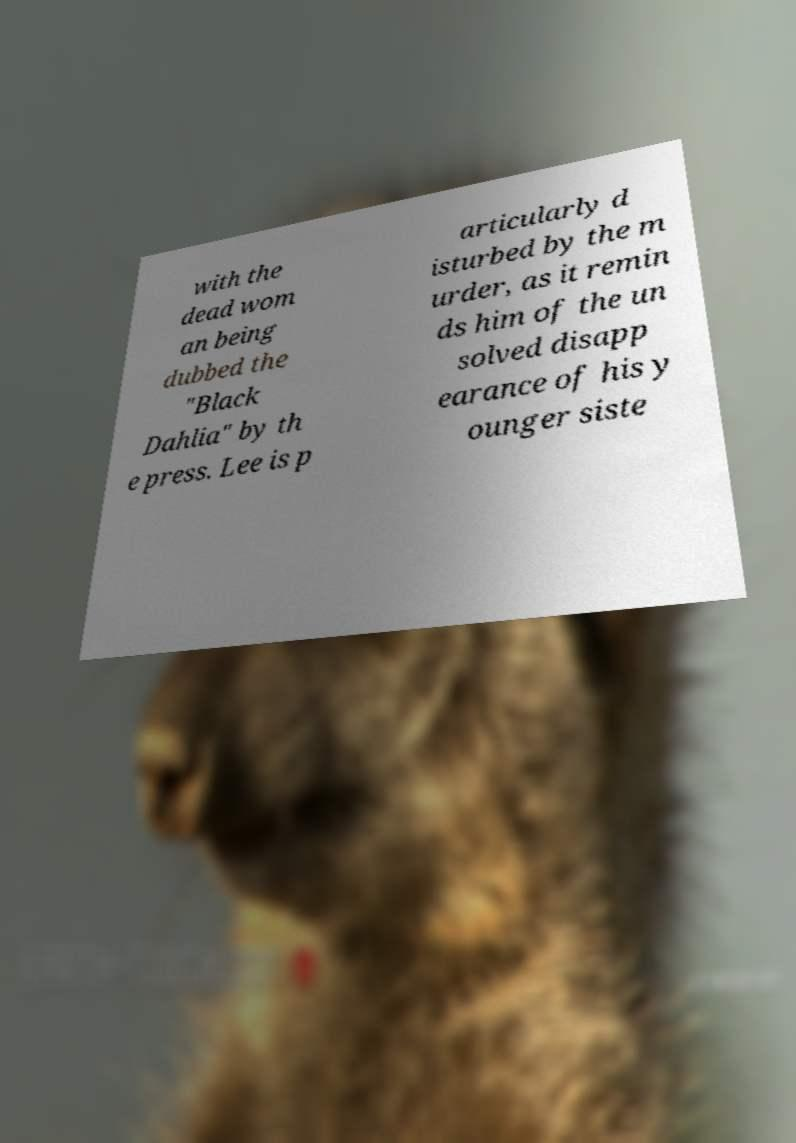There's text embedded in this image that I need extracted. Can you transcribe it verbatim? with the dead wom an being dubbed the "Black Dahlia" by th e press. Lee is p articularly d isturbed by the m urder, as it remin ds him of the un solved disapp earance of his y ounger siste 